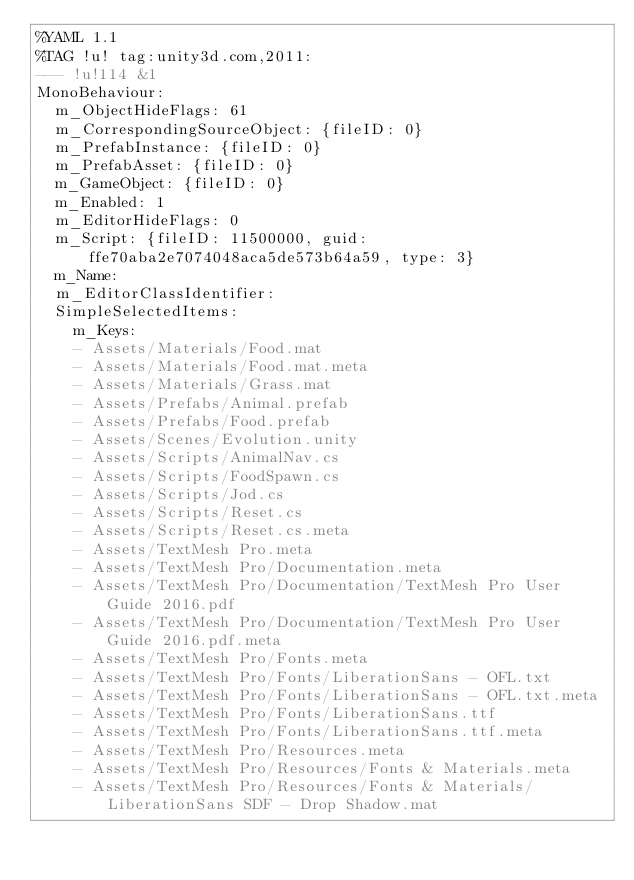<code> <loc_0><loc_0><loc_500><loc_500><_YAML_>%YAML 1.1
%TAG !u! tag:unity3d.com,2011:
--- !u!114 &1
MonoBehaviour:
  m_ObjectHideFlags: 61
  m_CorrespondingSourceObject: {fileID: 0}
  m_PrefabInstance: {fileID: 0}
  m_PrefabAsset: {fileID: 0}
  m_GameObject: {fileID: 0}
  m_Enabled: 1
  m_EditorHideFlags: 0
  m_Script: {fileID: 11500000, guid: ffe70aba2e7074048aca5de573b64a59, type: 3}
  m_Name: 
  m_EditorClassIdentifier: 
  SimpleSelectedItems:
    m_Keys:
    - Assets/Materials/Food.mat
    - Assets/Materials/Food.mat.meta
    - Assets/Materials/Grass.mat
    - Assets/Prefabs/Animal.prefab
    - Assets/Prefabs/Food.prefab
    - Assets/Scenes/Evolution.unity
    - Assets/Scripts/AnimalNav.cs
    - Assets/Scripts/FoodSpawn.cs
    - Assets/Scripts/Jod.cs
    - Assets/Scripts/Reset.cs
    - Assets/Scripts/Reset.cs.meta
    - Assets/TextMesh Pro.meta
    - Assets/TextMesh Pro/Documentation.meta
    - Assets/TextMesh Pro/Documentation/TextMesh Pro User Guide 2016.pdf
    - Assets/TextMesh Pro/Documentation/TextMesh Pro User Guide 2016.pdf.meta
    - Assets/TextMesh Pro/Fonts.meta
    - Assets/TextMesh Pro/Fonts/LiberationSans - OFL.txt
    - Assets/TextMesh Pro/Fonts/LiberationSans - OFL.txt.meta
    - Assets/TextMesh Pro/Fonts/LiberationSans.ttf
    - Assets/TextMesh Pro/Fonts/LiberationSans.ttf.meta
    - Assets/TextMesh Pro/Resources.meta
    - Assets/TextMesh Pro/Resources/Fonts & Materials.meta
    - Assets/TextMesh Pro/Resources/Fonts & Materials/LiberationSans SDF - Drop Shadow.mat</code> 